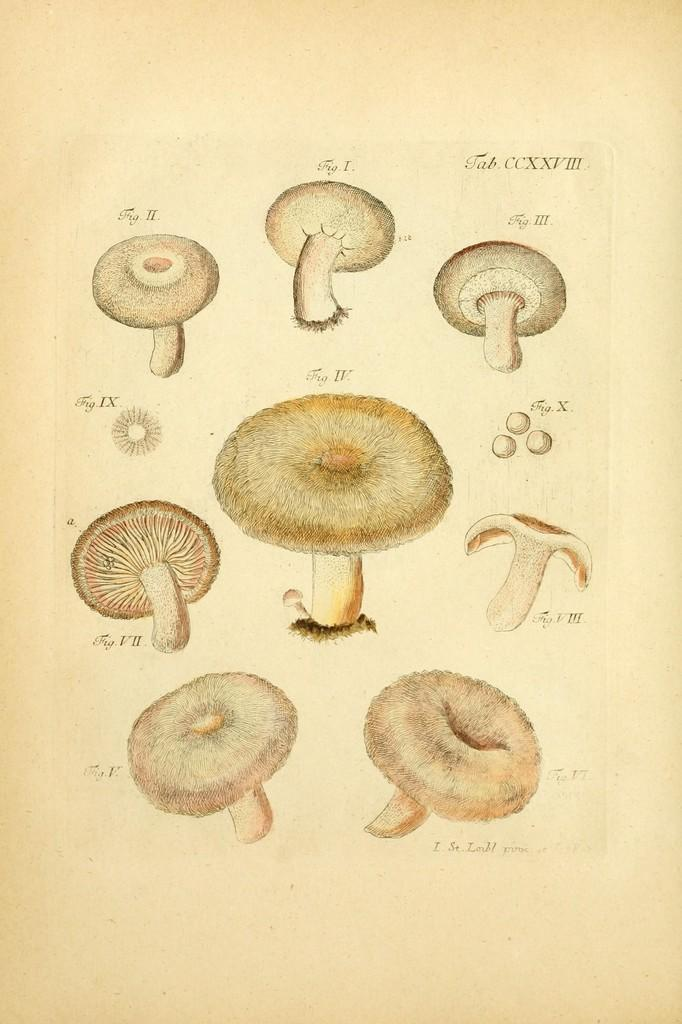What is depicted in the drawings in the image? The drawings in the image are of mushrooms. On what surface are the drawings made? The drawings are on a paper. What type of building can be seen in the background of the image? There is no building present in the image; it only features drawings of mushrooms on a paper. 